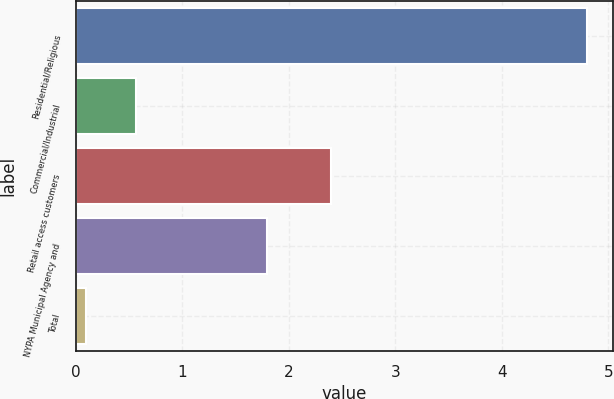Convert chart. <chart><loc_0><loc_0><loc_500><loc_500><bar_chart><fcel>Residential/Religious<fcel>Commercial/Industrial<fcel>Retail access customers<fcel>NYPA Municipal Agency and<fcel>Total<nl><fcel>4.8<fcel>0.57<fcel>2.4<fcel>1.8<fcel>0.1<nl></chart> 